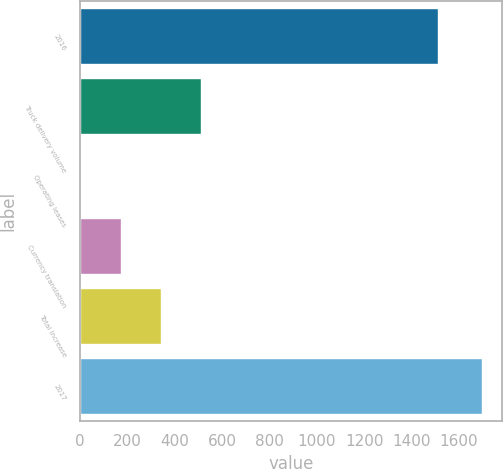Convert chart to OTSL. <chart><loc_0><loc_0><loc_500><loc_500><bar_chart><fcel>2016<fcel>Truck delivery volume<fcel>Operating leases<fcel>Currency translation<fcel>Total increase<fcel>2017<nl><fcel>1510.5<fcel>511.22<fcel>2.9<fcel>172.34<fcel>341.78<fcel>1697.3<nl></chart> 